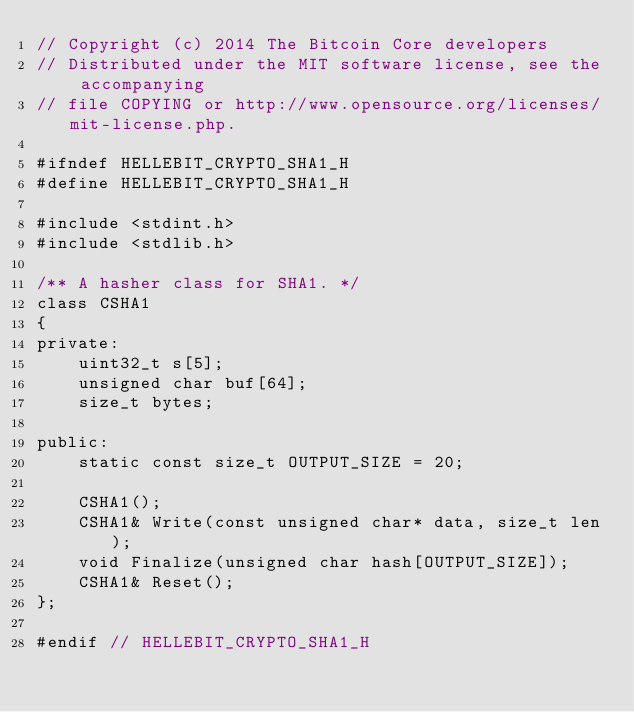Convert code to text. <code><loc_0><loc_0><loc_500><loc_500><_C_>// Copyright (c) 2014 The Bitcoin Core developers
// Distributed under the MIT software license, see the accompanying
// file COPYING or http://www.opensource.org/licenses/mit-license.php.

#ifndef HELLEBIT_CRYPTO_SHA1_H
#define HELLEBIT_CRYPTO_SHA1_H

#include <stdint.h>
#include <stdlib.h>

/** A hasher class for SHA1. */
class CSHA1
{
private:
    uint32_t s[5];
    unsigned char buf[64];
    size_t bytes;

public:
    static const size_t OUTPUT_SIZE = 20;

    CSHA1();
    CSHA1& Write(const unsigned char* data, size_t len);
    void Finalize(unsigned char hash[OUTPUT_SIZE]);
    CSHA1& Reset();
};

#endif // HELLEBIT_CRYPTO_SHA1_H
</code> 